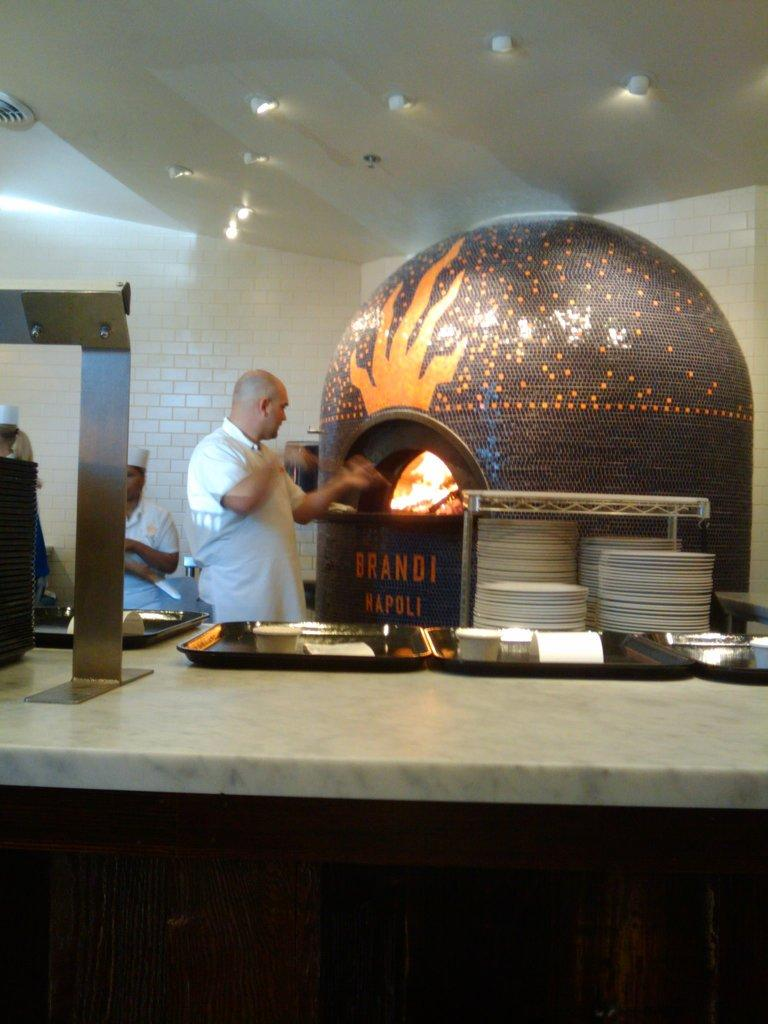<image>
Summarize the visual content of the image. A man beside an indoor brick oven with a the words Brandi Napoli on the oven 